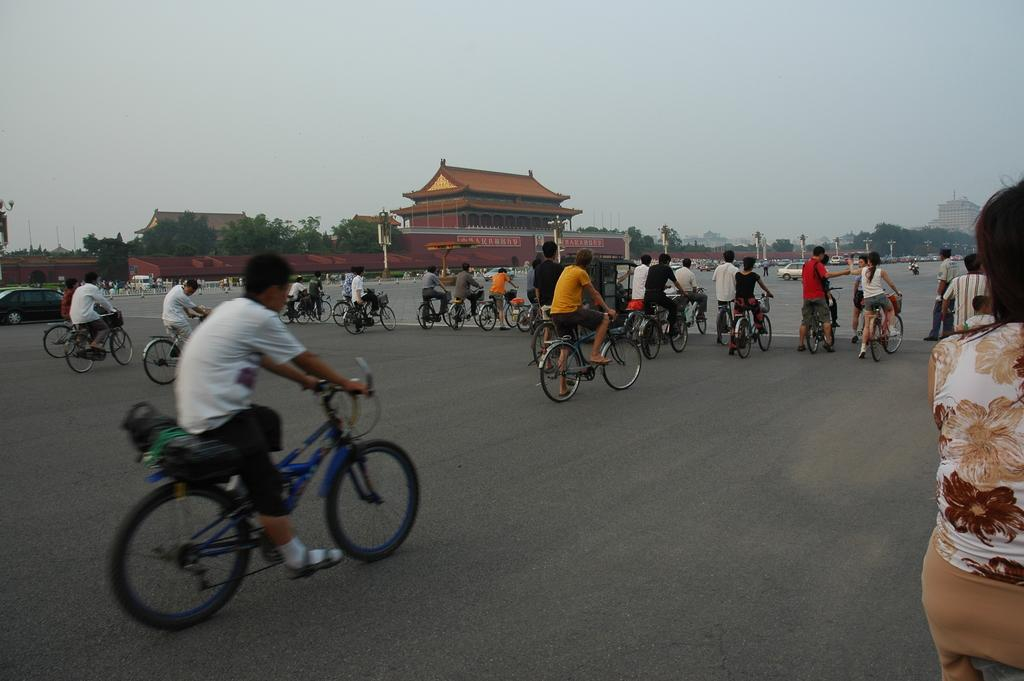What are the people in the image doing? The people in the image are cycling. What type of vehicles can be seen in the image? There are vehicles in the image. What else is present in the image besides people cycling and vehicles? There are trees in the image. Can you see any feathers falling from the sky in the image? There are no feathers or falling motion visible in the image. 